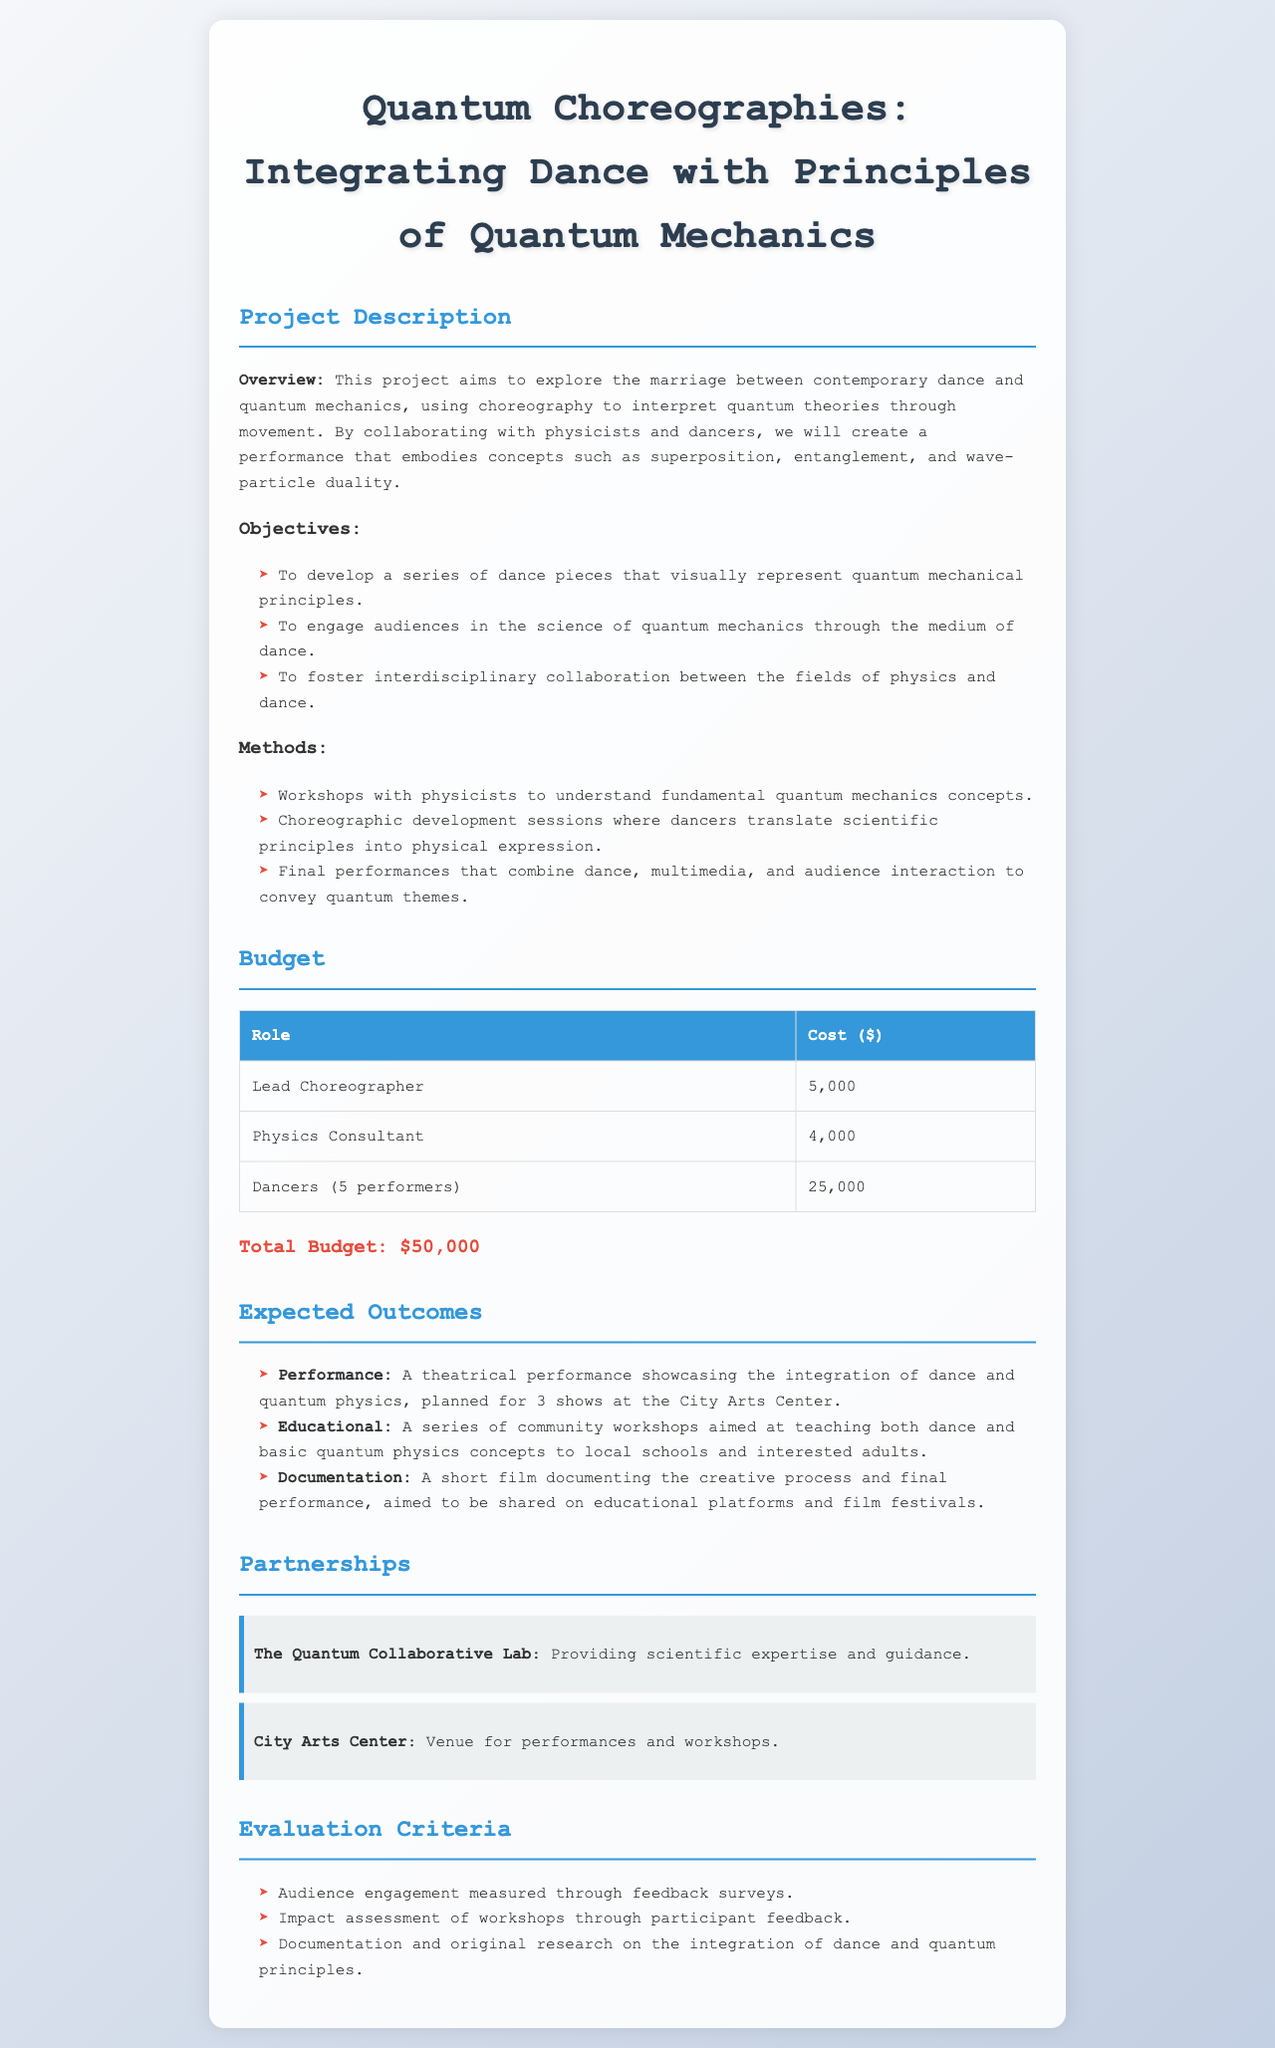What is the title of the project? The title of the project is mentioned at the beginning of the document.
Answer: Quantum Choreographies: Integrating Dance with Principles of Quantum Mechanics Who is the lead choreographer? The document lists the roles and their associated costs, including the lead choreographer.
Answer: Lead Choreographer What is the total budget for the project? The total budget is provided at the end of the budget section.
Answer: $50,000 How many dancers are involved in the project? The budget section indicates the number of dancers participating in the project.
Answer: 5 performers What is one objective of the project? Objectives are summarized in a list format, and one of them is to engage audiences.
Answer: To engage audiences in the science of quantum mechanics through the medium of dance What organization is providing scientific expertise? The partnerships section explicitly mentions the organization providing guidance.
Answer: The Quantum Collaborative Lab How many performances are planned? The expected outcomes section states the number of shows planned at the City Arts Center.
Answer: 3 shows What type of workshops will be conducted? The expected outcomes detail the type of workshops to be conducted pertaining to dance and quantum physics.
Answer: Community workshops What is one method used in the project? The methods section outlines various strategies employed in the project; one is workshops with physicists.
Answer: Workshops with physicists to understand fundamental quantum mechanics concepts 